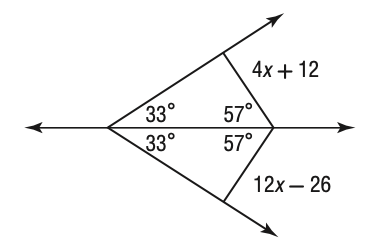Answer the mathemtical geometry problem and directly provide the correct option letter.
Question: Solve for x in the figure below.
Choices: A: 1.75 B: 2 C: 2.375 D: 4.75 D 